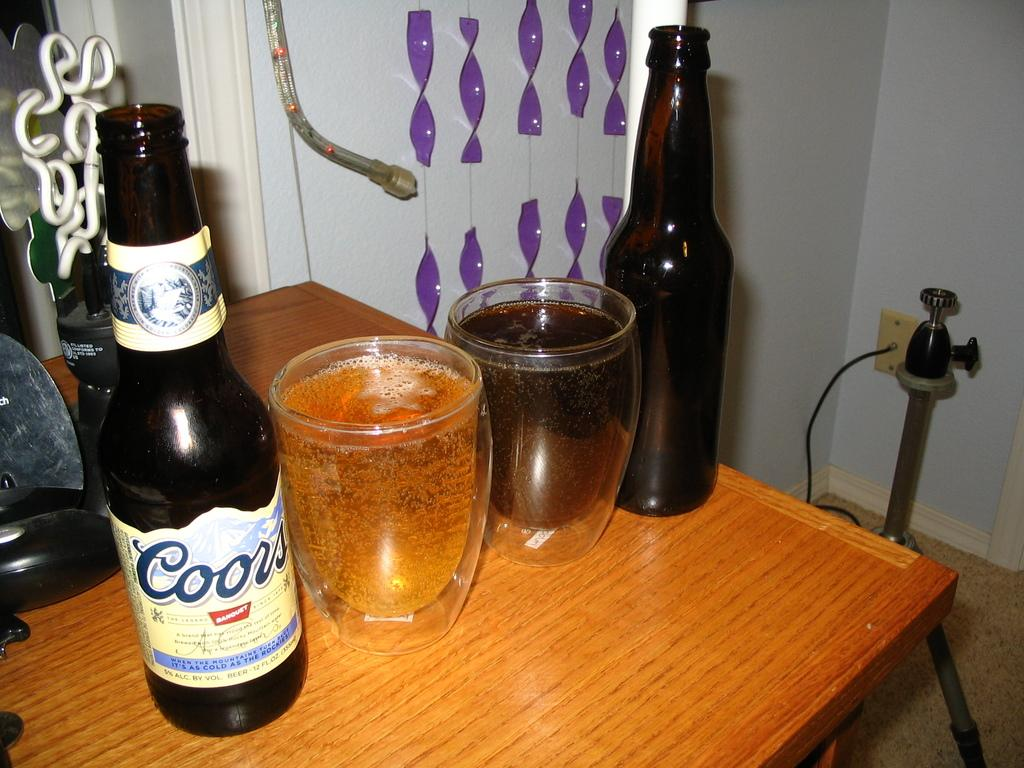<image>
Present a compact description of the photo's key features. Coors beer bottle with two glasses sitting on a table 